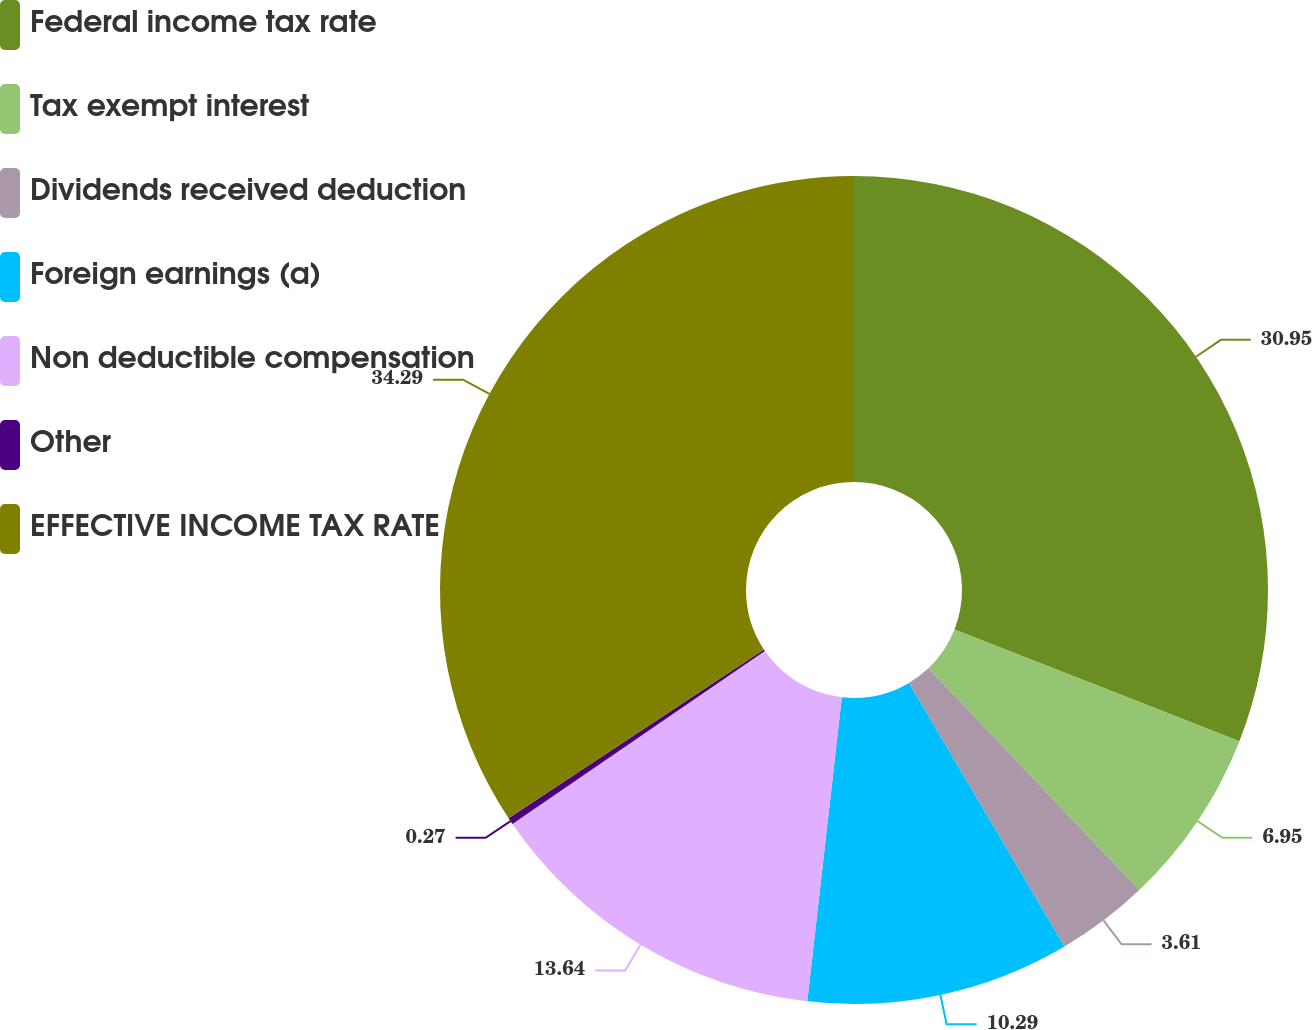<chart> <loc_0><loc_0><loc_500><loc_500><pie_chart><fcel>Federal income tax rate<fcel>Tax exempt interest<fcel>Dividends received deduction<fcel>Foreign earnings (a)<fcel>Non deductible compensation<fcel>Other<fcel>EFFECTIVE INCOME TAX RATE<nl><fcel>30.95%<fcel>6.95%<fcel>3.61%<fcel>10.29%<fcel>13.64%<fcel>0.27%<fcel>34.29%<nl></chart> 